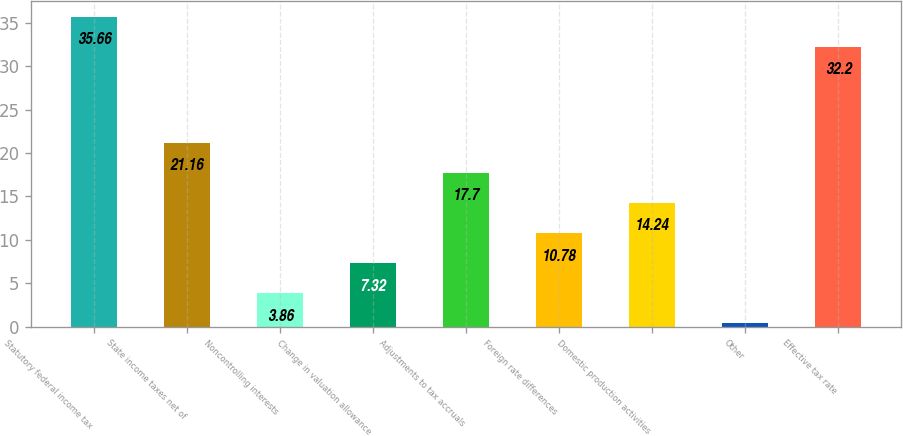<chart> <loc_0><loc_0><loc_500><loc_500><bar_chart><fcel>Statutory federal income tax<fcel>State income taxes net of<fcel>Noncontrolling interests<fcel>Change in valuation allowance<fcel>Adjustments to tax accruals<fcel>Foreign rate differences<fcel>Domestic production activities<fcel>Other<fcel>Effective tax rate<nl><fcel>35.66<fcel>21.16<fcel>3.86<fcel>7.32<fcel>17.7<fcel>10.78<fcel>14.24<fcel>0.4<fcel>32.2<nl></chart> 